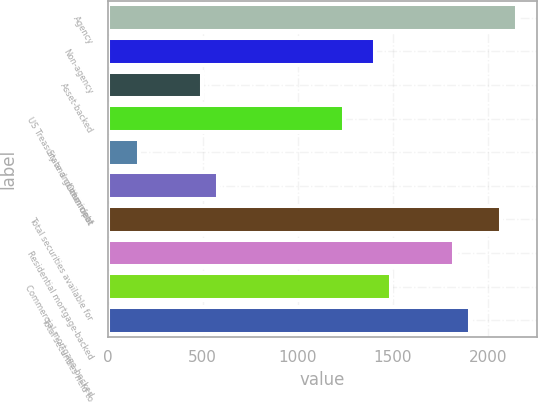Convert chart. <chart><loc_0><loc_0><loc_500><loc_500><bar_chart><fcel>Agency<fcel>Non-agency<fcel>Asset-backed<fcel>US Treasury and government<fcel>State and municipal<fcel>Other debt<fcel>Total securities available for<fcel>Residential mortgage-backed<fcel>Commercial mortgage-backed<fcel>Total securities held to<nl><fcel>2153.8<fcel>1408.6<fcel>497.8<fcel>1243<fcel>166.6<fcel>580.6<fcel>2071<fcel>1822.6<fcel>1491.4<fcel>1905.4<nl></chart> 